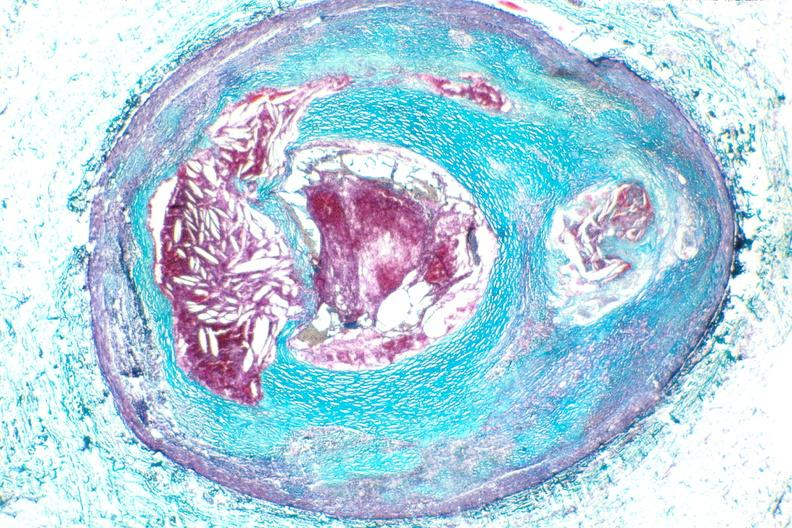s intraductal papillomatosis with apocrine metaplasia present?
Answer the question using a single word or phrase. No 